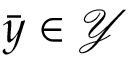<formula> <loc_0><loc_0><loc_500><loc_500>\bar { y } \in \mathcal { Y }</formula> 